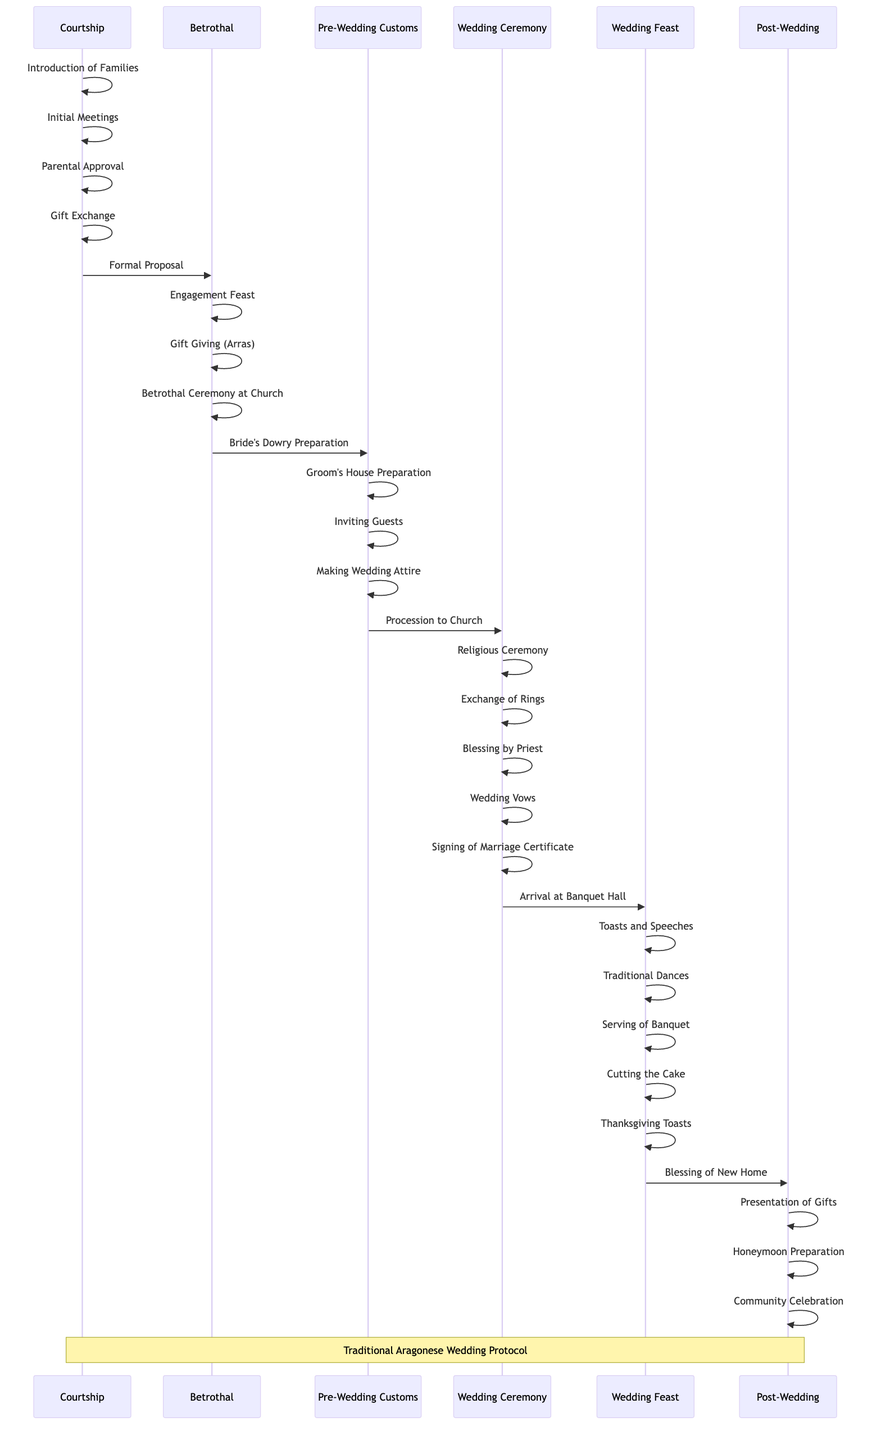What is the first step in the sequence of events? The first step is 'Introduction of Families' which is part of the 'Courtship' phase.
Answer: Introduction of Families How many steps are present in the 'Wedding Ceremony'? There are six elements in the 'Wedding Ceremony', which include Procession to Church, Religious Ceremony, Exchange of Rings, Blessing by Priest, Wedding Vows, and Signing of Marriage Certificate.
Answer: 6 Which elements directly follow the 'Betrothal'? After 'Betrothal', the next phase is 'Pre-Wedding Customs', which includes elements like Bride's Dowry Preparation and Groom's House Preparation.
Answer: Pre-Wedding Customs What event concludes the 'Wedding Feast'? The 'Wedding Feast' concludes with the 'Thanksgiving Toasts' element, marking the final ceremony in that phase.
Answer: Thanksgiving Toasts What is the last phase in the sequence diagram? The last phase is 'Post-Wedding', which contains elements such as Blessing of New Home and Community Celebration.
Answer: Post-Wedding What specific gift is involved during the 'Betrothal'? The specific gift involved during the 'Betrothal' is 'Gift Giving (Arras)', which signifies the groom's commitment.
Answer: Gift Giving (Arras) Which two phases involve preparation activities? The 'Pre-Wedding Customs' and 'Post-Wedding' phases both include preparation activities, with the first focusing on wedding logistics and the second on moving into a new home.
Answer: Pre-Wedding Customs, Post-Wedding How many total phases are depicted in this sequence diagram? There are six total phases depicted in the sequence diagram, listed as Courtship, Betrothal, Pre-Wedding Customs, Wedding Ceremony, Wedding Feast, and Post-Wedding.
Answer: 6 What happens immediately after the 'Exchange of Rings'? Immediately after the 'Exchange of Rings' is the 'Blessing by Priest', which is a traditional aspect of the ceremony.
Answer: Blessing by Priest 